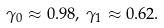<formula> <loc_0><loc_0><loc_500><loc_500>\gamma _ { 0 } \approx 0 . 9 8 , \, \gamma _ { 1 } \approx 0 . 6 2 .</formula> 